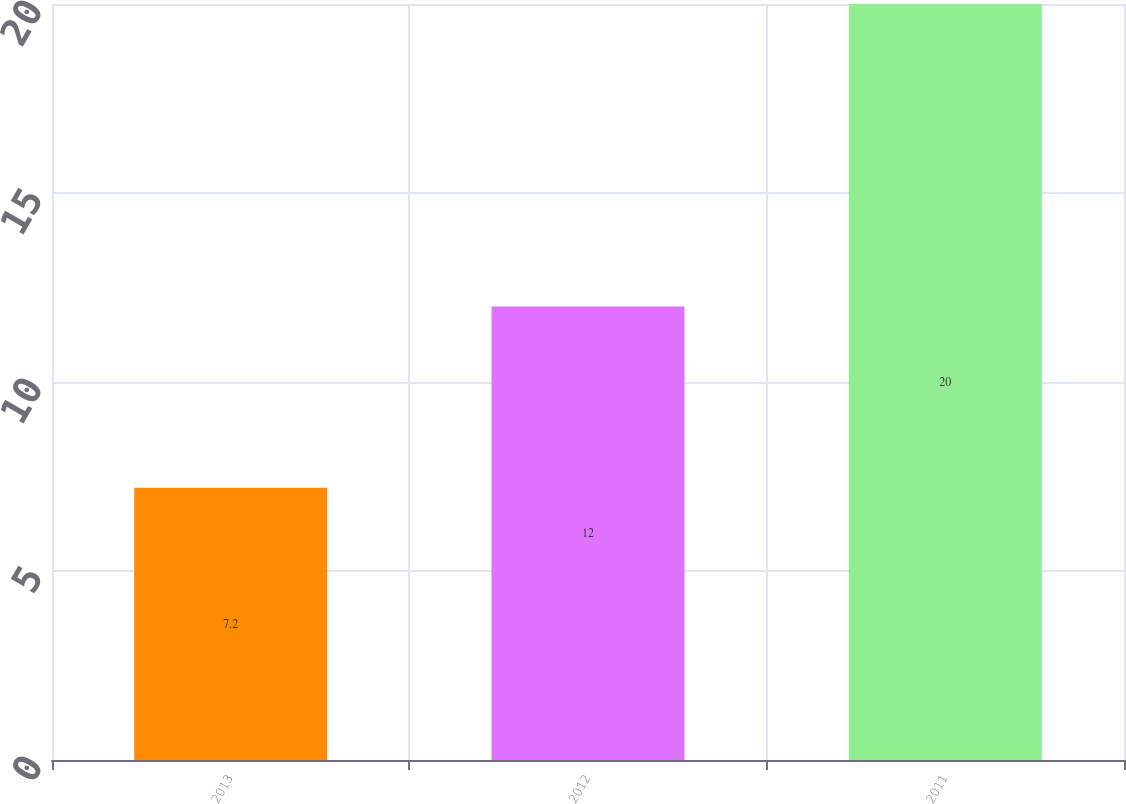Convert chart to OTSL. <chart><loc_0><loc_0><loc_500><loc_500><bar_chart><fcel>2013<fcel>2012<fcel>2011<nl><fcel>7.2<fcel>12<fcel>20<nl></chart> 